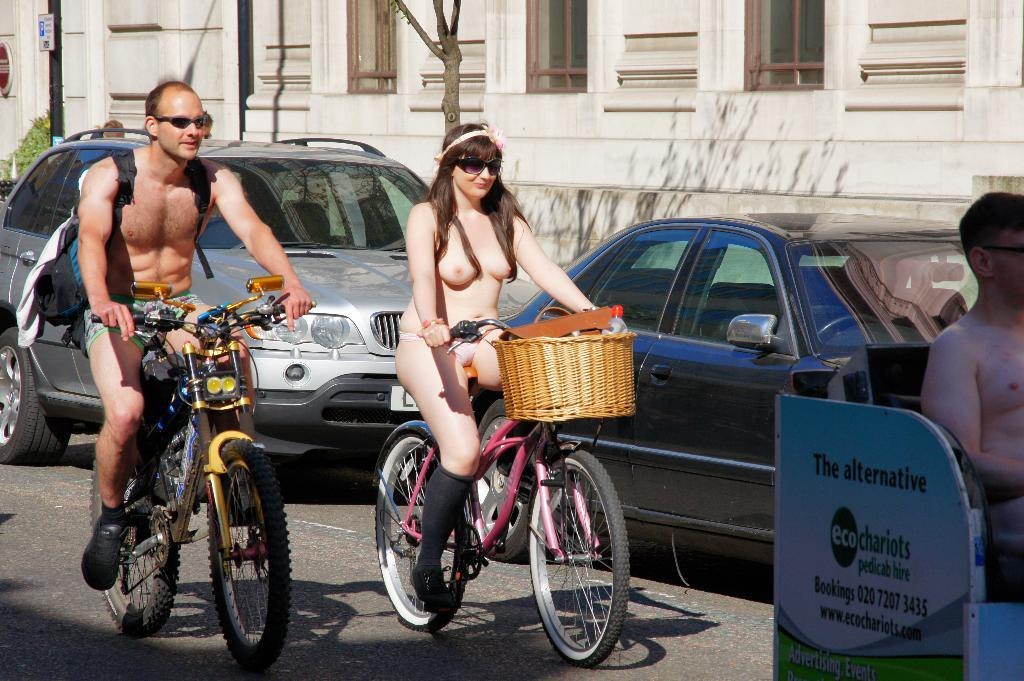How many people are in the image? There are two persons in the image. What are the persons doing in the image? The persons are riding bicycles. What can be seen in the background of the image? There is a building, a tree, and vehicles in the background of the image. What type of behavior is the church exhibiting in the image? There is no church present in the image, so it is not possible to determine its behavior. 